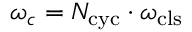<formula> <loc_0><loc_0><loc_500><loc_500>\omega _ { c } = N _ { c y c } \cdot \omega _ { c l s }</formula> 